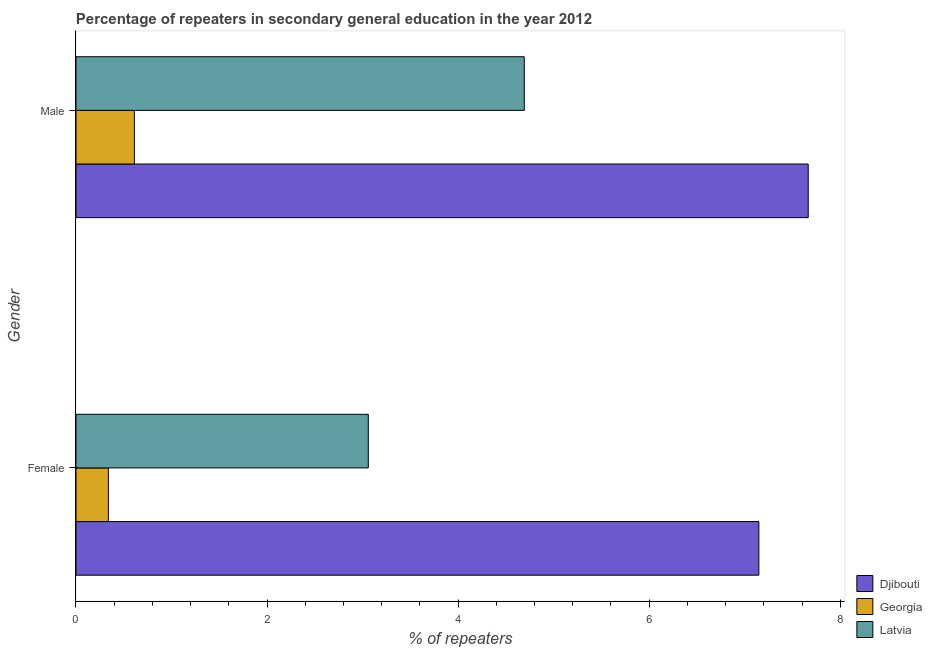How many groups of bars are there?
Keep it short and to the point. 2. Are the number of bars on each tick of the Y-axis equal?
Provide a succinct answer. Yes. How many bars are there on the 1st tick from the bottom?
Offer a very short reply. 3. What is the percentage of female repeaters in Djibouti?
Give a very brief answer. 7.15. Across all countries, what is the maximum percentage of female repeaters?
Give a very brief answer. 7.15. Across all countries, what is the minimum percentage of female repeaters?
Make the answer very short. 0.34. In which country was the percentage of female repeaters maximum?
Give a very brief answer. Djibouti. In which country was the percentage of female repeaters minimum?
Your response must be concise. Georgia. What is the total percentage of female repeaters in the graph?
Ensure brevity in your answer.  10.55. What is the difference between the percentage of female repeaters in Latvia and that in Georgia?
Keep it short and to the point. 2.72. What is the difference between the percentage of male repeaters in Georgia and the percentage of female repeaters in Latvia?
Give a very brief answer. -2.45. What is the average percentage of male repeaters per country?
Provide a succinct answer. 4.32. What is the difference between the percentage of male repeaters and percentage of female repeaters in Djibouti?
Make the answer very short. 0.52. What is the ratio of the percentage of female repeaters in Latvia to that in Georgia?
Provide a succinct answer. 9.03. What does the 1st bar from the top in Male represents?
Provide a succinct answer. Latvia. What does the 3rd bar from the bottom in Female represents?
Provide a short and direct response. Latvia. How many countries are there in the graph?
Keep it short and to the point. 3. Does the graph contain any zero values?
Provide a short and direct response. No. Where does the legend appear in the graph?
Your answer should be compact. Bottom right. How many legend labels are there?
Ensure brevity in your answer.  3. How are the legend labels stacked?
Provide a succinct answer. Vertical. What is the title of the graph?
Provide a succinct answer. Percentage of repeaters in secondary general education in the year 2012. Does "Ecuador" appear as one of the legend labels in the graph?
Offer a terse response. No. What is the label or title of the X-axis?
Ensure brevity in your answer.  % of repeaters. What is the % of repeaters of Djibouti in Female?
Provide a succinct answer. 7.15. What is the % of repeaters in Georgia in Female?
Offer a terse response. 0.34. What is the % of repeaters in Latvia in Female?
Your answer should be compact. 3.06. What is the % of repeaters in Djibouti in Male?
Give a very brief answer. 7.66. What is the % of repeaters in Georgia in Male?
Keep it short and to the point. 0.61. What is the % of repeaters of Latvia in Male?
Provide a short and direct response. 4.69. Across all Gender, what is the maximum % of repeaters in Djibouti?
Your response must be concise. 7.66. Across all Gender, what is the maximum % of repeaters of Georgia?
Provide a short and direct response. 0.61. Across all Gender, what is the maximum % of repeaters in Latvia?
Provide a succinct answer. 4.69. Across all Gender, what is the minimum % of repeaters of Djibouti?
Provide a short and direct response. 7.15. Across all Gender, what is the minimum % of repeaters of Georgia?
Your response must be concise. 0.34. Across all Gender, what is the minimum % of repeaters of Latvia?
Your response must be concise. 3.06. What is the total % of repeaters in Djibouti in the graph?
Your response must be concise. 14.81. What is the total % of repeaters in Latvia in the graph?
Your response must be concise. 7.75. What is the difference between the % of repeaters of Djibouti in Female and that in Male?
Make the answer very short. -0.52. What is the difference between the % of repeaters in Georgia in Female and that in Male?
Provide a succinct answer. -0.27. What is the difference between the % of repeaters of Latvia in Female and that in Male?
Keep it short and to the point. -1.63. What is the difference between the % of repeaters in Djibouti in Female and the % of repeaters in Georgia in Male?
Make the answer very short. 6.54. What is the difference between the % of repeaters in Djibouti in Female and the % of repeaters in Latvia in Male?
Offer a very short reply. 2.46. What is the difference between the % of repeaters in Georgia in Female and the % of repeaters in Latvia in Male?
Keep it short and to the point. -4.35. What is the average % of repeaters of Djibouti per Gender?
Your answer should be compact. 7.41. What is the average % of repeaters of Georgia per Gender?
Your answer should be compact. 0.47. What is the average % of repeaters in Latvia per Gender?
Keep it short and to the point. 3.88. What is the difference between the % of repeaters in Djibouti and % of repeaters in Georgia in Female?
Offer a very short reply. 6.81. What is the difference between the % of repeaters of Djibouti and % of repeaters of Latvia in Female?
Keep it short and to the point. 4.09. What is the difference between the % of repeaters in Georgia and % of repeaters in Latvia in Female?
Offer a terse response. -2.72. What is the difference between the % of repeaters of Djibouti and % of repeaters of Georgia in Male?
Keep it short and to the point. 7.05. What is the difference between the % of repeaters in Djibouti and % of repeaters in Latvia in Male?
Offer a terse response. 2.97. What is the difference between the % of repeaters of Georgia and % of repeaters of Latvia in Male?
Offer a terse response. -4.08. What is the ratio of the % of repeaters in Djibouti in Female to that in Male?
Offer a terse response. 0.93. What is the ratio of the % of repeaters in Georgia in Female to that in Male?
Provide a short and direct response. 0.55. What is the ratio of the % of repeaters in Latvia in Female to that in Male?
Ensure brevity in your answer.  0.65. What is the difference between the highest and the second highest % of repeaters of Djibouti?
Your answer should be compact. 0.52. What is the difference between the highest and the second highest % of repeaters of Georgia?
Offer a very short reply. 0.27. What is the difference between the highest and the second highest % of repeaters in Latvia?
Your answer should be very brief. 1.63. What is the difference between the highest and the lowest % of repeaters in Djibouti?
Offer a very short reply. 0.52. What is the difference between the highest and the lowest % of repeaters in Georgia?
Offer a terse response. 0.27. What is the difference between the highest and the lowest % of repeaters of Latvia?
Offer a terse response. 1.63. 